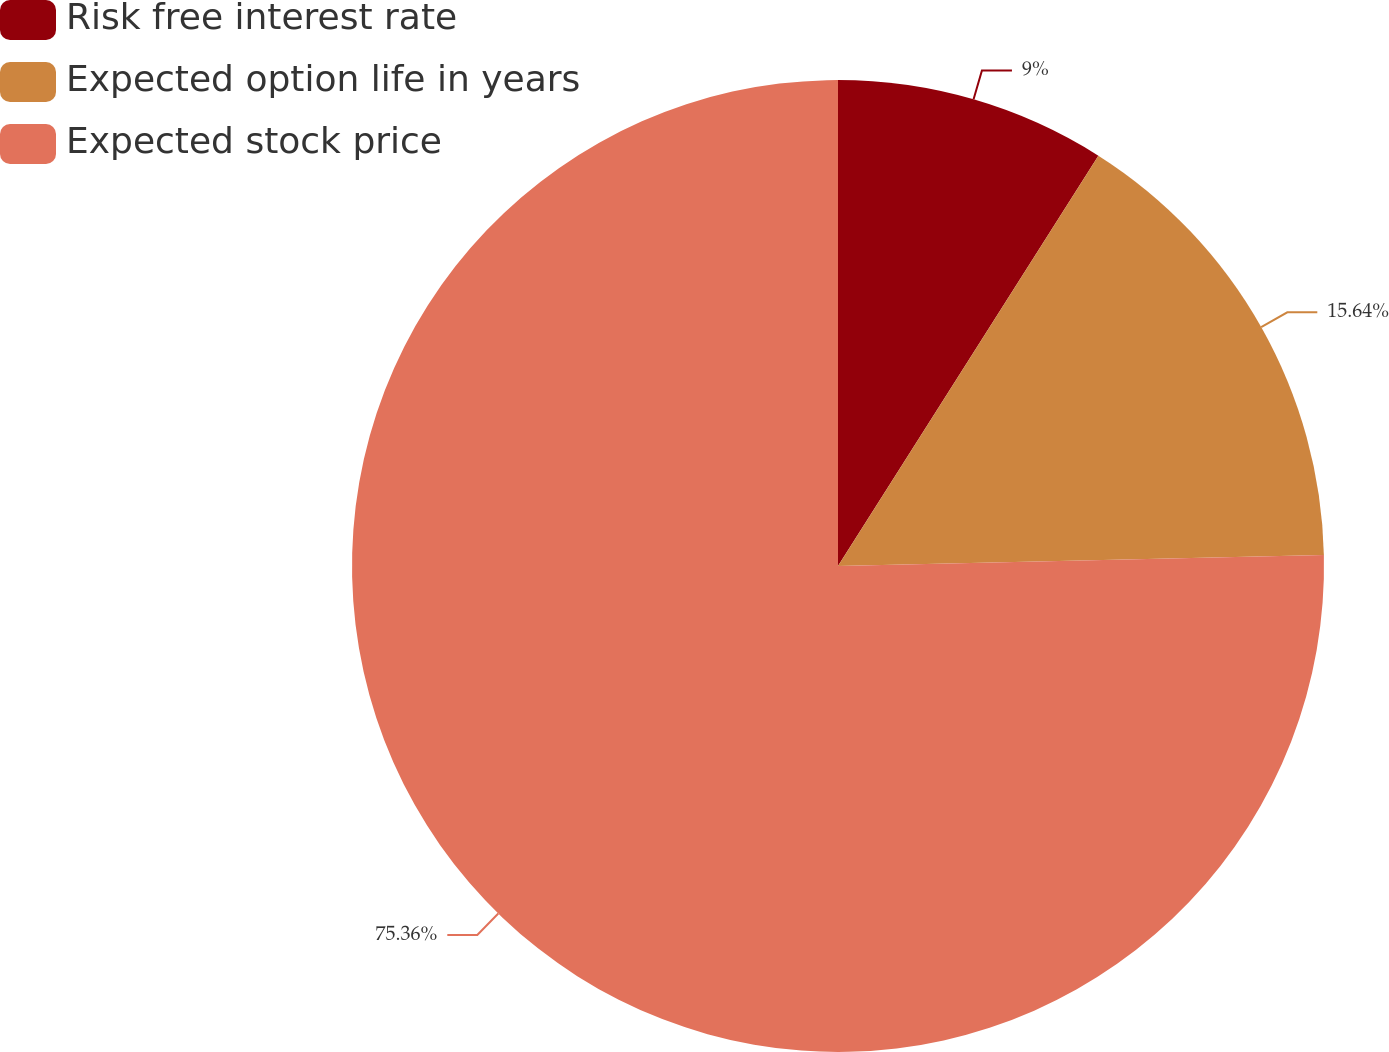Convert chart. <chart><loc_0><loc_0><loc_500><loc_500><pie_chart><fcel>Risk free interest rate<fcel>Expected option life in years<fcel>Expected stock price<nl><fcel>9.0%<fcel>15.64%<fcel>75.37%<nl></chart> 